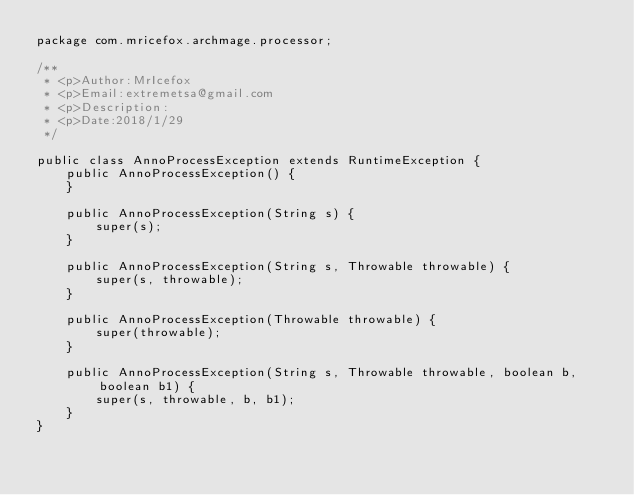<code> <loc_0><loc_0><loc_500><loc_500><_Java_>package com.mricefox.archmage.processor;

/**
 * <p>Author:MrIcefox
 * <p>Email:extremetsa@gmail.com
 * <p>Description:
 * <p>Date:2018/1/29
 */

public class AnnoProcessException extends RuntimeException {
    public AnnoProcessException() {
    }

    public AnnoProcessException(String s) {
        super(s);
    }

    public AnnoProcessException(String s, Throwable throwable) {
        super(s, throwable);
    }

    public AnnoProcessException(Throwable throwable) {
        super(throwable);
    }

    public AnnoProcessException(String s, Throwable throwable, boolean b, boolean b1) {
        super(s, throwable, b, b1);
    }
}
</code> 